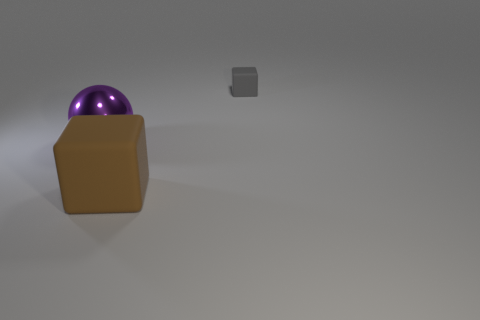Add 3 tiny gray matte things. How many objects exist? 6 Subtract 1 blocks. How many blocks are left? 1 Subtract all blue cylinders. How many brown blocks are left? 1 Subtract all small blue metal cylinders. Subtract all metallic balls. How many objects are left? 2 Add 2 big purple things. How many big purple things are left? 3 Add 3 big brown matte things. How many big brown matte things exist? 4 Subtract 0 gray cylinders. How many objects are left? 3 Subtract all cubes. How many objects are left? 1 Subtract all blue spheres. Subtract all cyan cubes. How many spheres are left? 1 